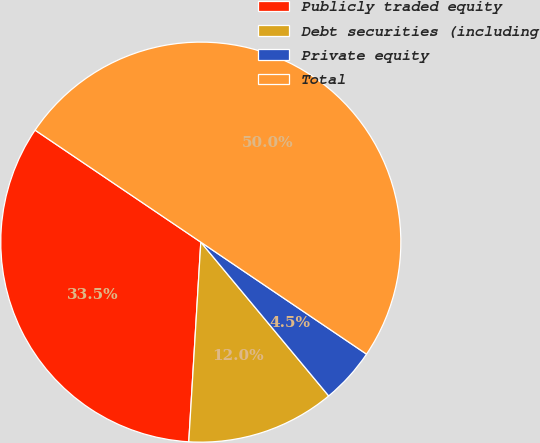Convert chart. <chart><loc_0><loc_0><loc_500><loc_500><pie_chart><fcel>Publicly traded equity<fcel>Debt securities (including<fcel>Private equity<fcel>Total<nl><fcel>33.5%<fcel>12.0%<fcel>4.5%<fcel>50.0%<nl></chart> 